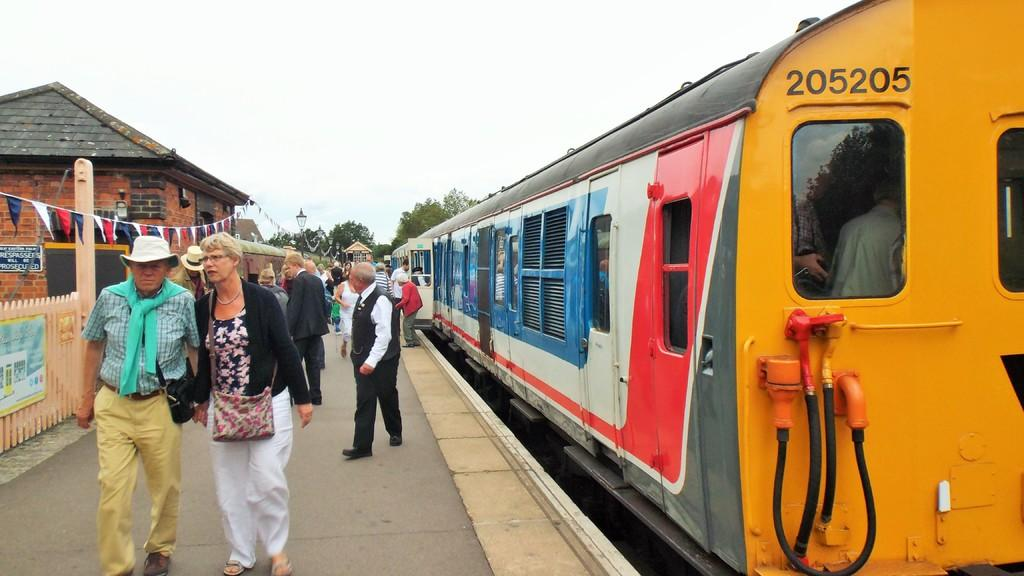What can be seen on the platform in the image? There are a few people on the platform in the image. What is the main mode of transportation in the image? There is a train in the image. What type of barrier is present in the image? There is fencing in the image. What decorative elements are present in the image? Small flags are present in the image. What type of structure is visible in the image? There is a house in the image. What type of vegetation is visible in the image? Trees are visible in the image. What type of illumination is present in the image? Lights are present in the image. What part of the natural environment is visible in the image? The sky is visible in the image. Where is the church located in the image? There is no church present in the image. Who is sitting on the throne in the image? There is no throne present in the image. What is the sister doing in the image? There is no mention of a sister in the image. 